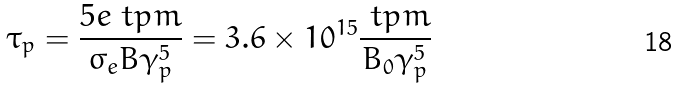<formula> <loc_0><loc_0><loc_500><loc_500>\tau _ { p } = \frac { 5 e \ t p m } { \sigma _ { e } B \gamma _ { p } ^ { 5 } } = 3 . 6 \times 1 0 ^ { 1 5 } \frac { \ t p m } { B _ { 0 } \gamma _ { p } ^ { 5 } }</formula> 